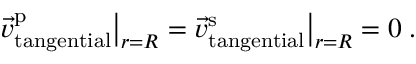Convert formula to latex. <formula><loc_0><loc_0><loc_500><loc_500>\vec { v } _ { t a n g e n t i a l } ^ { p } \left | _ { r = R } = \vec { v } _ { t a n g e n t i a l } ^ { s } \right | _ { r = R } = 0 \, .</formula> 